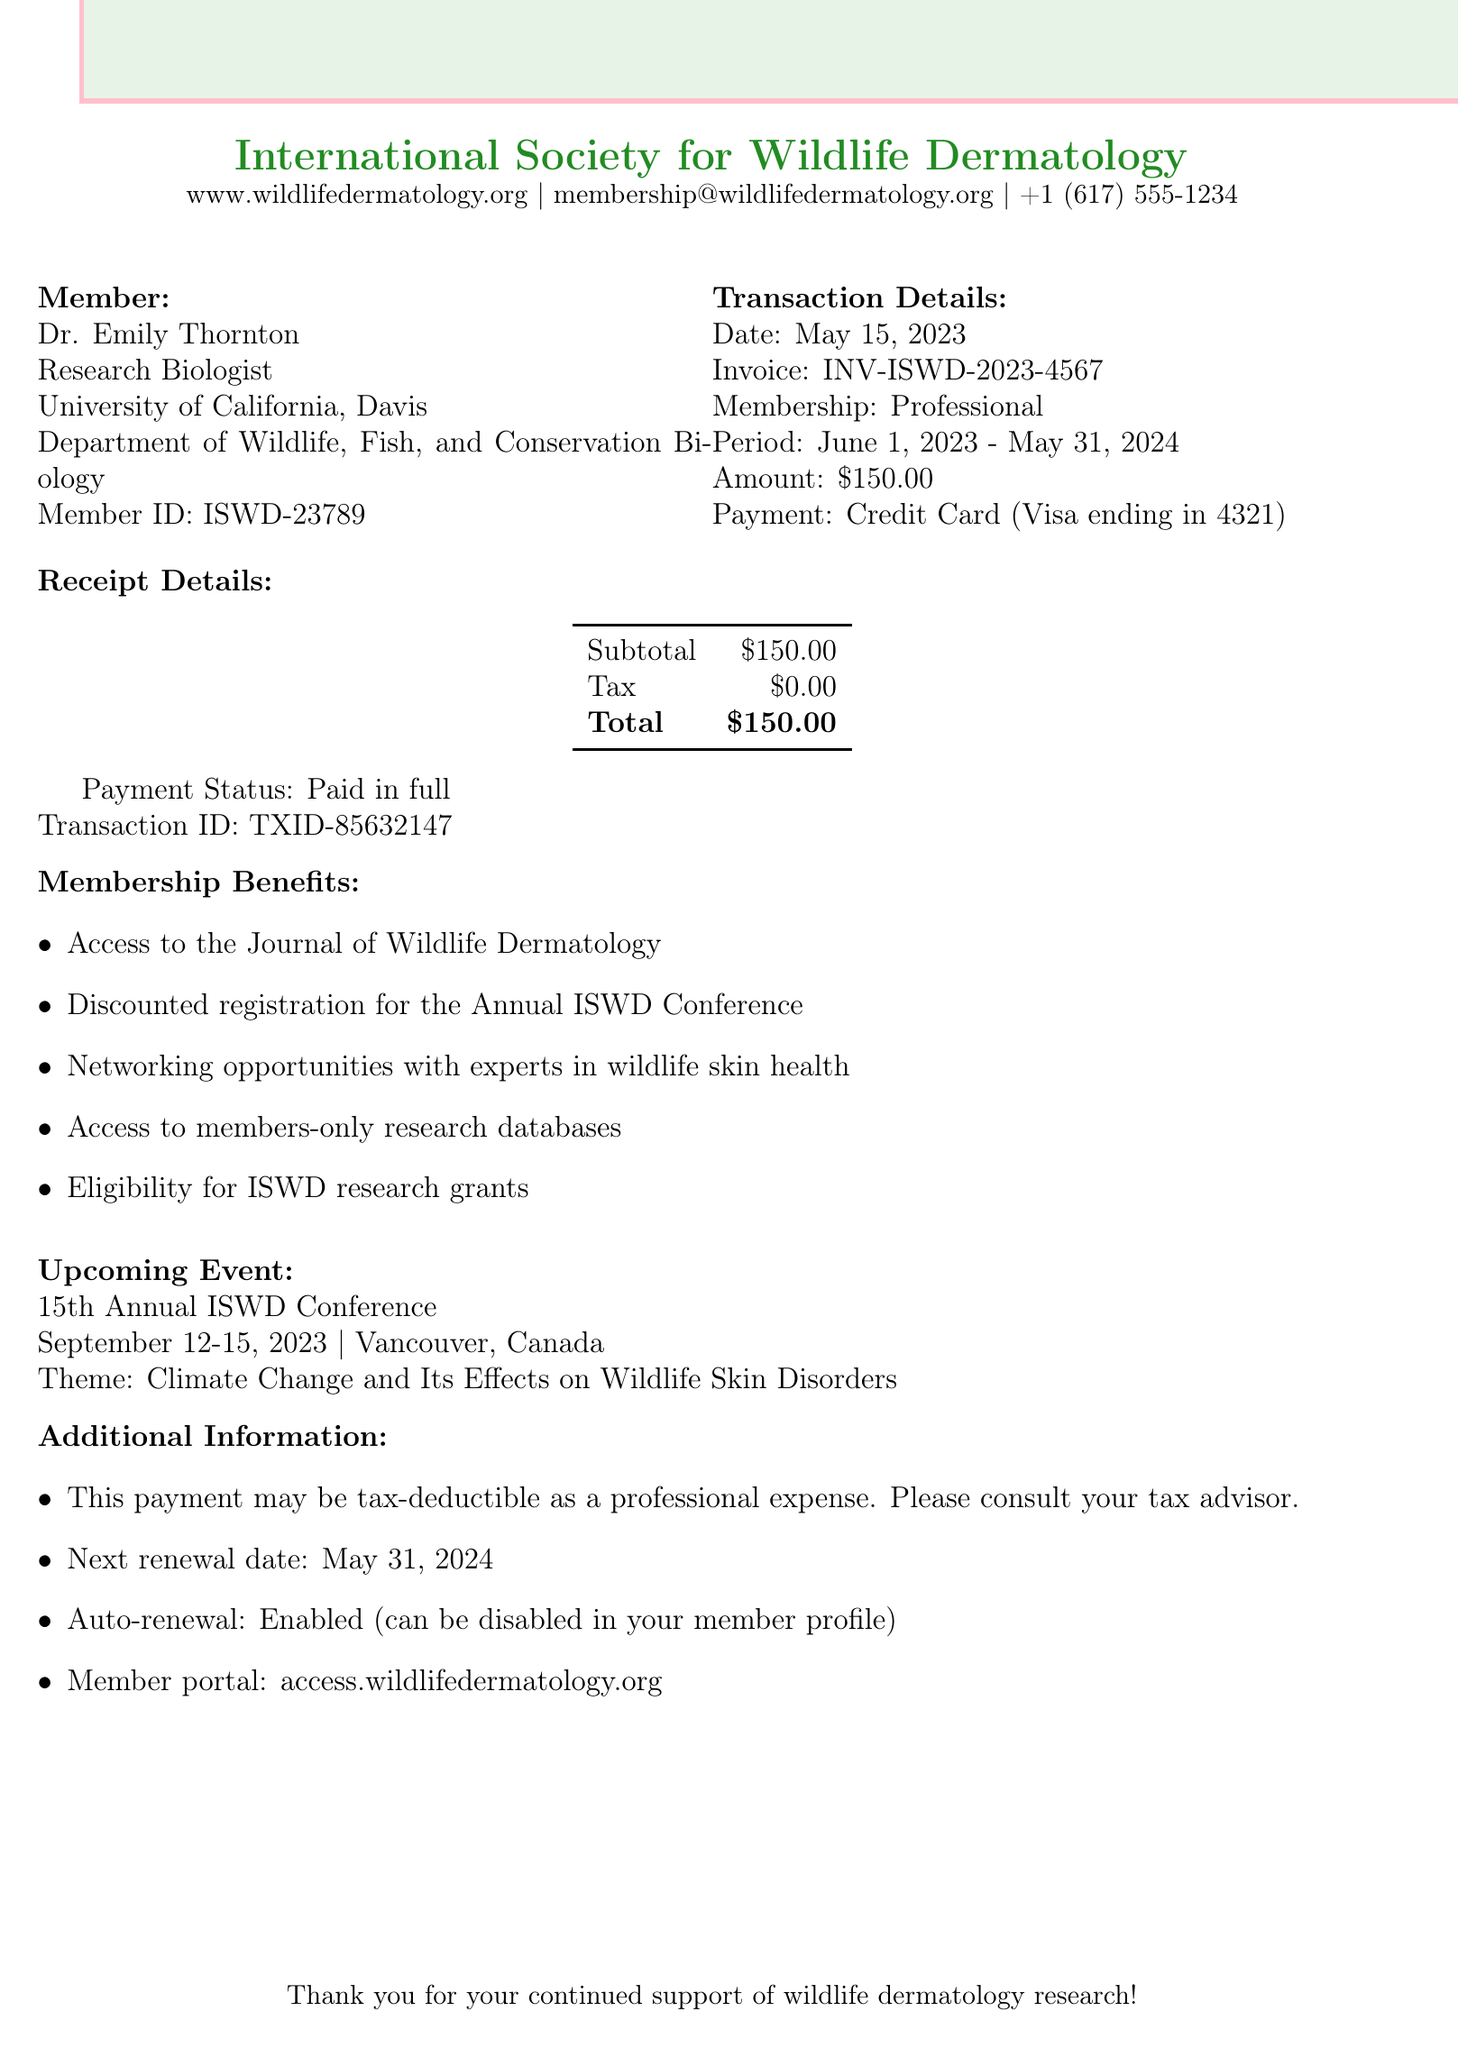What is the name of the organization? The name of the organization is provided in the document, which is listed at the top.
Answer: International Society for Wildlife Dermatology What is Dr. Emily Thornton's title? Dr. Emily Thornton's title is specified in the member section of the document.
Answer: Research Biologist When does the membership renewal period start? The renewal period start date is mentioned in the transaction details.
Answer: June 1, 2023 What is the amount paid for membership renewal? The amount is clearly stated in the transaction details of the document.
Answer: $150.00 What is the tax status of the transaction? The tax information is available in the receipt details of the document.
Answer: $0.00 What are the benefits of membership? The document lists multiple membership benefits within a specific section.
Answer: Access to the Journal of Wildlife Dermatology What is the upcoming event and its theme? The document includes an upcoming event and its associated theme in a dedicated section.
Answer: 15th Annual ISWD Conference, Climate Change and Its Effects on Wildlife Skin Disorders What is the transaction ID for this payment? The transaction ID can be found in the receipt details of the document.
Answer: TXID-85632147 What is the next renewal date? The next renewal date is highlighted in the additional information section.
Answer: May 31, 2024 Is auto-renewal enabled for the membership? The document specifically mentions the auto-renewal status in the additional information section.
Answer: Enabled 